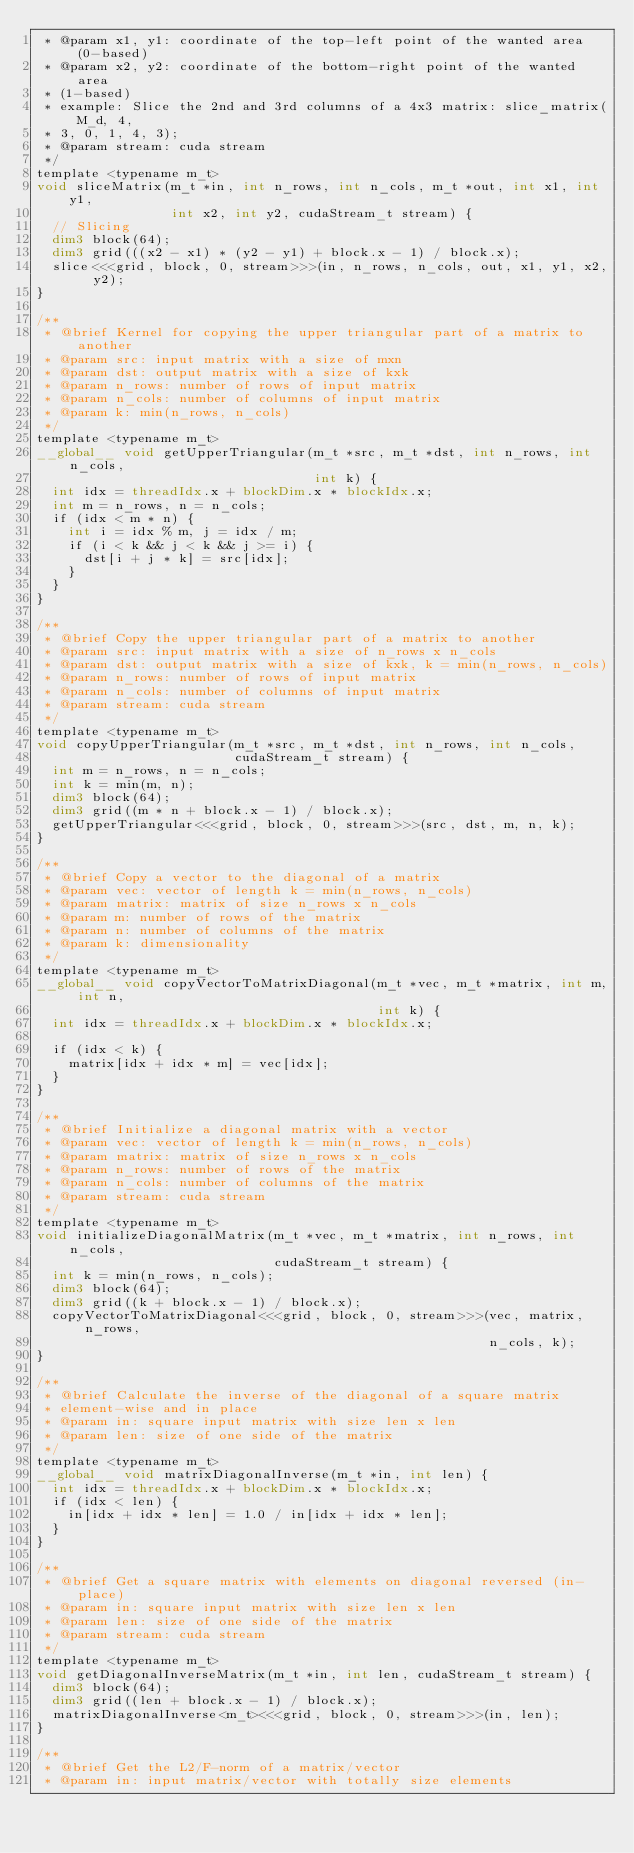<code> <loc_0><loc_0><loc_500><loc_500><_Cuda_> * @param x1, y1: coordinate of the top-left point of the wanted area (0-based)
 * @param x2, y2: coordinate of the bottom-right point of the wanted area
 * (1-based)
 * example: Slice the 2nd and 3rd columns of a 4x3 matrix: slice_matrix(M_d, 4,
 * 3, 0, 1, 4, 3);
 * @param stream: cuda stream
 */
template <typename m_t>
void sliceMatrix(m_t *in, int n_rows, int n_cols, m_t *out, int x1, int y1,
                 int x2, int y2, cudaStream_t stream) {
  // Slicing
  dim3 block(64);
  dim3 grid(((x2 - x1) * (y2 - y1) + block.x - 1) / block.x);
  slice<<<grid, block, 0, stream>>>(in, n_rows, n_cols, out, x1, y1, x2, y2);
}

/**
 * @brief Kernel for copying the upper triangular part of a matrix to another
 * @param src: input matrix with a size of mxn
 * @param dst: output matrix with a size of kxk
 * @param n_rows: number of rows of input matrix
 * @param n_cols: number of columns of input matrix
 * @param k: min(n_rows, n_cols)
 */
template <typename m_t>
__global__ void getUpperTriangular(m_t *src, m_t *dst, int n_rows, int n_cols,
                                   int k) {
  int idx = threadIdx.x + blockDim.x * blockIdx.x;
  int m = n_rows, n = n_cols;
  if (idx < m * n) {
    int i = idx % m, j = idx / m;
    if (i < k && j < k && j >= i) {
      dst[i + j * k] = src[idx];
    }
  }
}

/**
 * @brief Copy the upper triangular part of a matrix to another
 * @param src: input matrix with a size of n_rows x n_cols
 * @param dst: output matrix with a size of kxk, k = min(n_rows, n_cols)
 * @param n_rows: number of rows of input matrix
 * @param n_cols: number of columns of input matrix
 * @param stream: cuda stream
 */
template <typename m_t>
void copyUpperTriangular(m_t *src, m_t *dst, int n_rows, int n_cols,
                         cudaStream_t stream) {
  int m = n_rows, n = n_cols;
  int k = min(m, n);
  dim3 block(64);
  dim3 grid((m * n + block.x - 1) / block.x);
  getUpperTriangular<<<grid, block, 0, stream>>>(src, dst, m, n, k);
}

/**
 * @brief Copy a vector to the diagonal of a matrix
 * @param vec: vector of length k = min(n_rows, n_cols)
 * @param matrix: matrix of size n_rows x n_cols
 * @param m: number of rows of the matrix
 * @param n: number of columns of the matrix
 * @param k: dimensionality
 */
template <typename m_t>
__global__ void copyVectorToMatrixDiagonal(m_t *vec, m_t *matrix, int m, int n,
                                           int k) {
  int idx = threadIdx.x + blockDim.x * blockIdx.x;

  if (idx < k) {
    matrix[idx + idx * m] = vec[idx];
  }
}

/**
 * @brief Initialize a diagonal matrix with a vector
 * @param vec: vector of length k = min(n_rows, n_cols)
 * @param matrix: matrix of size n_rows x n_cols
 * @param n_rows: number of rows of the matrix
 * @param n_cols: number of columns of the matrix
 * @param stream: cuda stream
 */
template <typename m_t>
void initializeDiagonalMatrix(m_t *vec, m_t *matrix, int n_rows, int n_cols,
                              cudaStream_t stream) {
  int k = min(n_rows, n_cols);
  dim3 block(64);
  dim3 grid((k + block.x - 1) / block.x);
  copyVectorToMatrixDiagonal<<<grid, block, 0, stream>>>(vec, matrix, n_rows,
                                                         n_cols, k);
}

/**
 * @brief Calculate the inverse of the diagonal of a square matrix
 * element-wise and in place
 * @param in: square input matrix with size len x len
 * @param len: size of one side of the matrix
 */
template <typename m_t>
__global__ void matrixDiagonalInverse(m_t *in, int len) {
  int idx = threadIdx.x + blockDim.x * blockIdx.x;
  if (idx < len) {
    in[idx + idx * len] = 1.0 / in[idx + idx * len];
  }
}

/**
 * @brief Get a square matrix with elements on diagonal reversed (in-place)
 * @param in: square input matrix with size len x len
 * @param len: size of one side of the matrix
 * @param stream: cuda stream
 */
template <typename m_t>
void getDiagonalInverseMatrix(m_t *in, int len, cudaStream_t stream) {
  dim3 block(64);
  dim3 grid((len + block.x - 1) / block.x);
  matrixDiagonalInverse<m_t><<<grid, block, 0, stream>>>(in, len);
}

/**
 * @brief Get the L2/F-norm of a matrix/vector
 * @param in: input matrix/vector with totally size elements</code> 